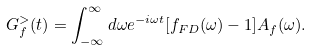<formula> <loc_0><loc_0><loc_500><loc_500>G _ { f } ^ { > } ( t ) = \int _ { - \infty } ^ { \infty } d \omega e ^ { - i \omega t } [ f _ { F D } ( \omega ) - 1 ] A _ { f } ( \omega ) .</formula> 